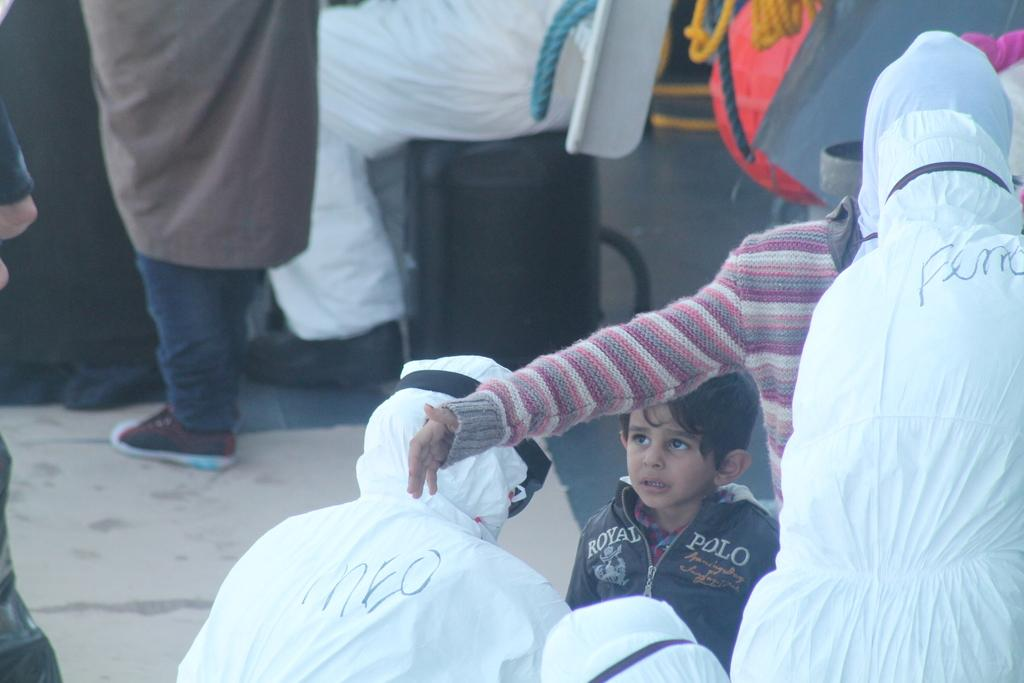How many people are in the image? There are multiple persons in the image. What are the people in the image doing? Some of the persons are standing, while others are sitting. Can you describe the object in the top right corner of the image? The object is red in color. What else can be seen in the image besides the people and the red object? There are ropes visible in the image. What is the average income of the people in the image? There is no information about the income of the people in the image, so it cannot be determined. What type of car is parked next to the people in the image? There is no car present in the image; it only features multiple persons, a red object, and ropes. 